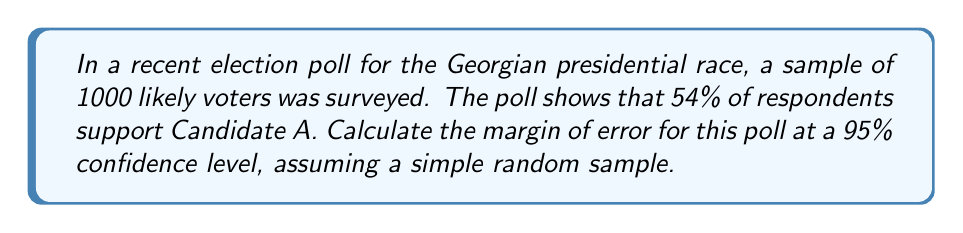Help me with this question. To calculate the margin of error for this poll, we'll follow these steps:

1. Identify the key information:
   - Sample size (n) = 1000
   - Proportion supporting Candidate A (p) = 0.54
   - Confidence level = 95%

2. For a 95% confidence level, the z-score (z) is 1.96.

3. The formula for margin of error (MOE) is:

   $$ MOE = z \sqrt{\frac{p(1-p)}{n}} $$

4. Substitute the values into the formula:

   $$ MOE = 1.96 \sqrt{\frac{0.54(1-0.54)}{1000}} $$

5. Simplify:
   $$ MOE = 1.96 \sqrt{\frac{0.54 \times 0.46}{1000}} $$
   $$ MOE = 1.96 \sqrt{\frac{0.2484}{1000}} $$
   $$ MOE = 1.96 \sqrt{0.0002484} $$
   $$ MOE = 1.96 \times 0.01576 $$
   $$ MOE = 0.03089 $$

6. Convert to percentage:
   $$ MOE = 3.089\% $$

7. Round to three decimal places:
   $$ MOE \approx 3.09\% $$

This means that we can be 95% confident that the true proportion of voters supporting Candidate A in the entire population is within ±3.09 percentage points of the sample estimate of 54%.
Answer: 3.09% 